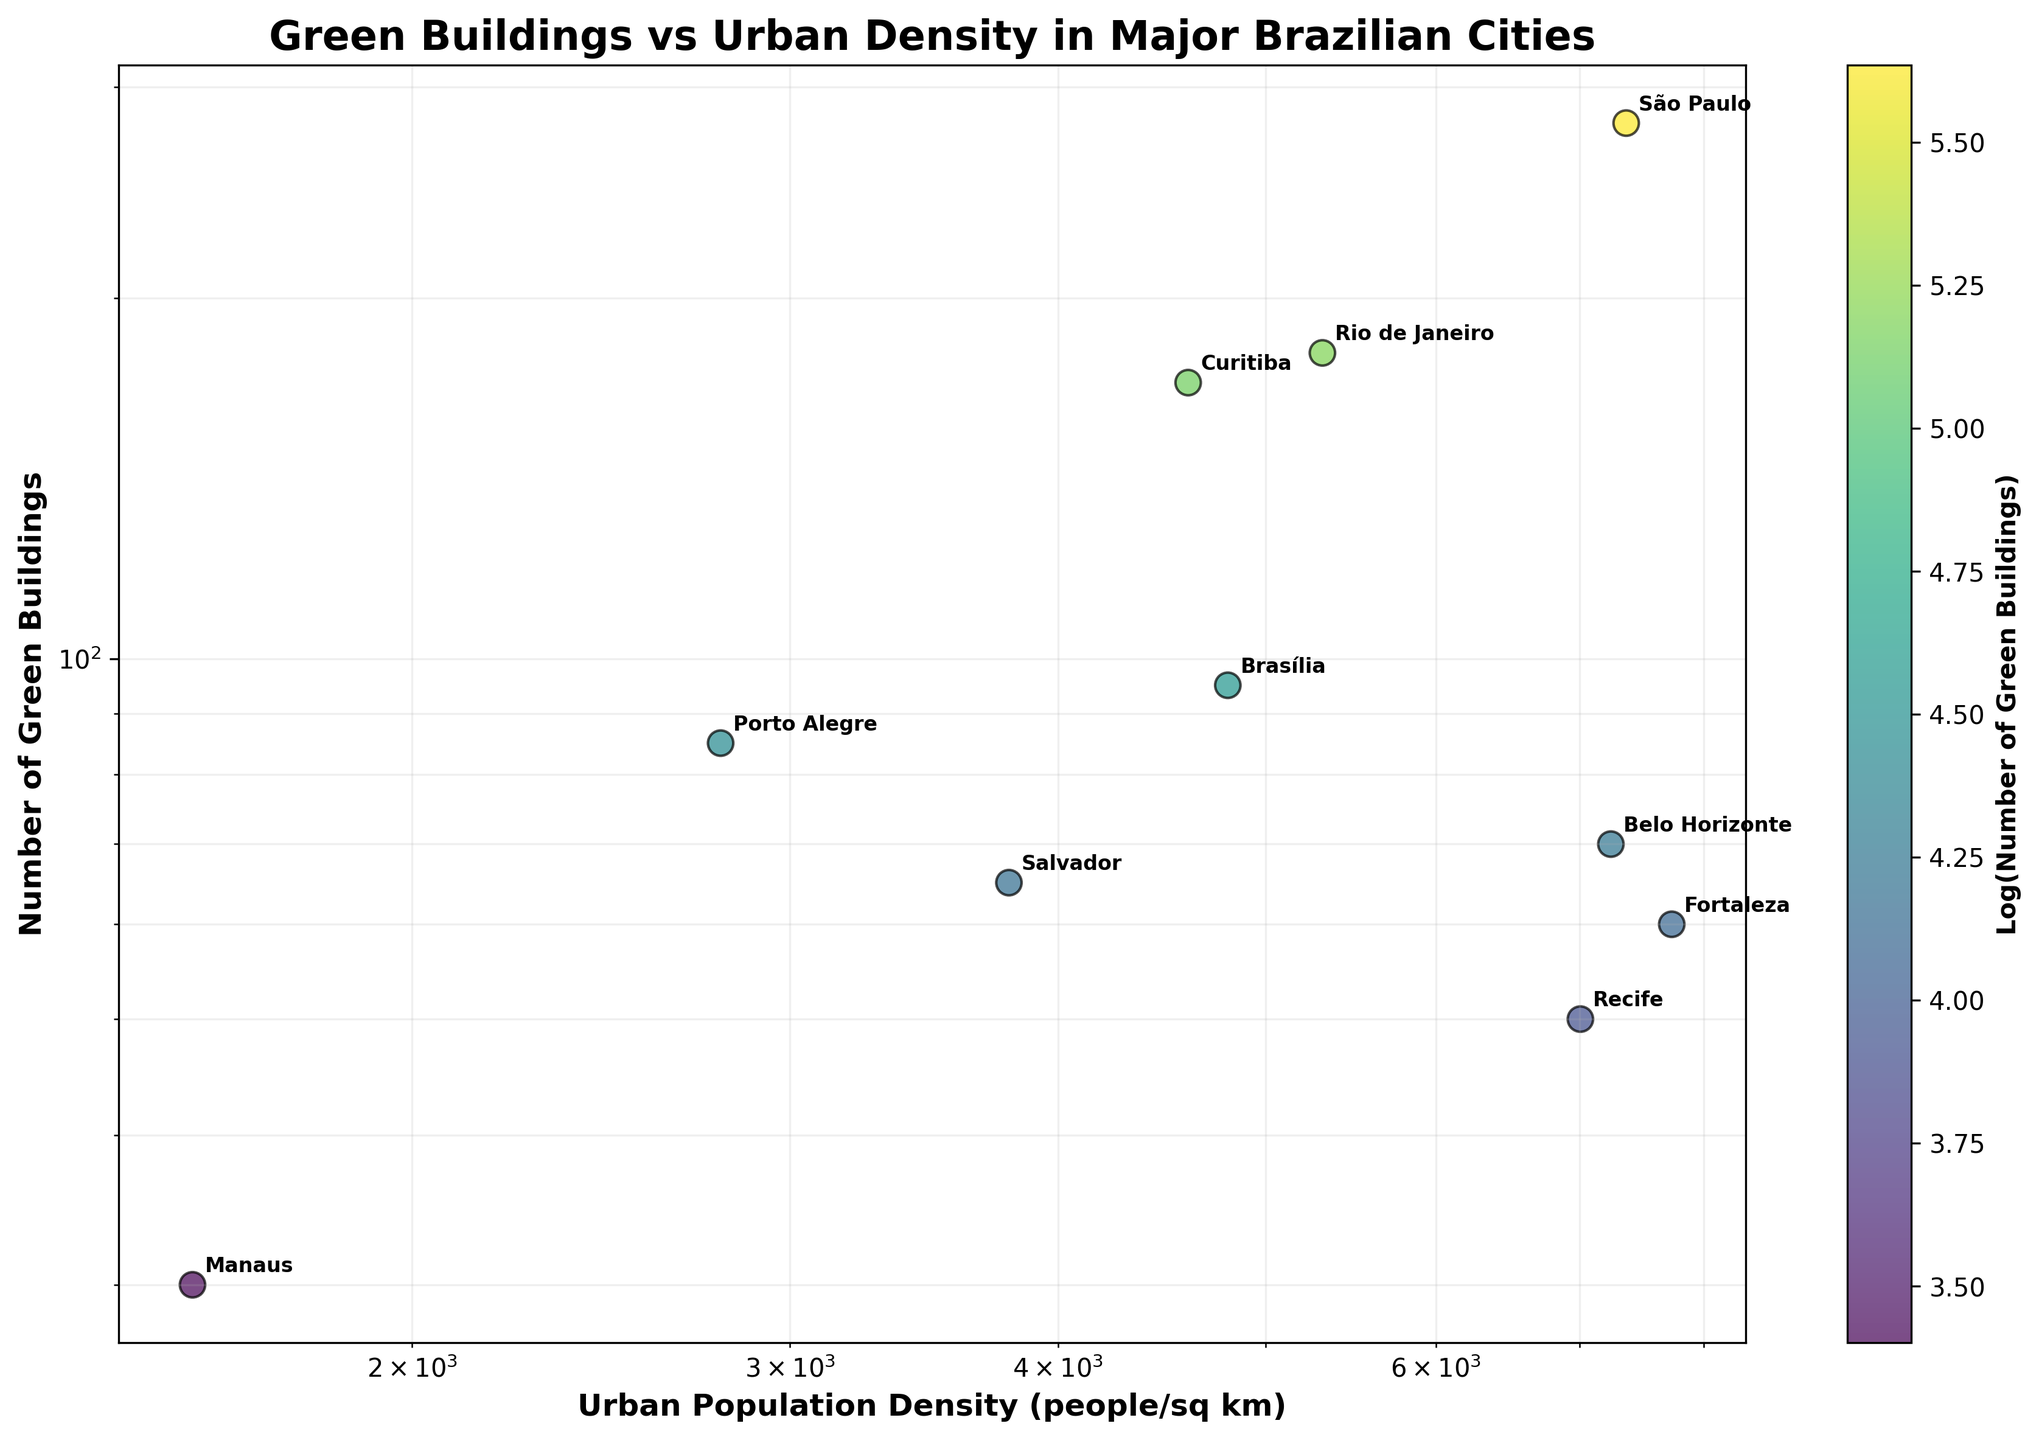What is the title of the plot? The title is located at the top of the figure and is written in bold font. It summarizes what the scatter plot is depicting.
Answer: Green Buildings vs Urban Density in Major Brazilian Cities How many cities are represented in the plot? Each data point on the scatter plot represents a city. Count the number of data points to find the answer.
Answer: 10 What is the approximate urban population density of Fortaleza? Locate the data point labeled "Fortaleza" on the x-axis and read its corresponding value.
Answer: 7730 people/sq km Which city has the highest number of green buildings? Find the data point with the highest value on the y-axis and refer to its label.
Answer: São Paulo Which city has the lowest urban population density? Look for the data point with the smallest x-axis value and refer to the city's name.
Answer: Manaus Which city has a similar number of green buildings to Brasília but a different urban population density? Identify the data point labeled "Brasília" and then find another data point with a similar y-axis value but different x-axis value.
Answer: Porto Alegre What is the relationship between urban population density and the number of green buildings in São Paulo compared to Rio de Janeiro? Compare the x-axis and y-axis values of the data points labeled "São Paulo" and "Rio de Janeiro." São Paulo has higher values in both axes compared to Rio de Janeiro.
Answer: São Paulo has higher urban density and more green buildings Which city has a higher number of green buildings: Curitiba or Recife? Compare the y-axis values of the data points labeled "Curitiba" and "Recife."
Answer: Curitiba How does the urban population density of Salvador compare to that of Porto Alegre? Locate the data points labeled "Salvador" and "Porto Alegre" and compare their x-axis values.
Answer: Salvador has a higher urban density What pattern is noticeable in the plot between urban population density and the number of green buildings? Analyze the scatter plot to identify any visible trend or correlation between the two variables.
Answer: Higher urban population density appears to be associated with a higher number of green buildings 